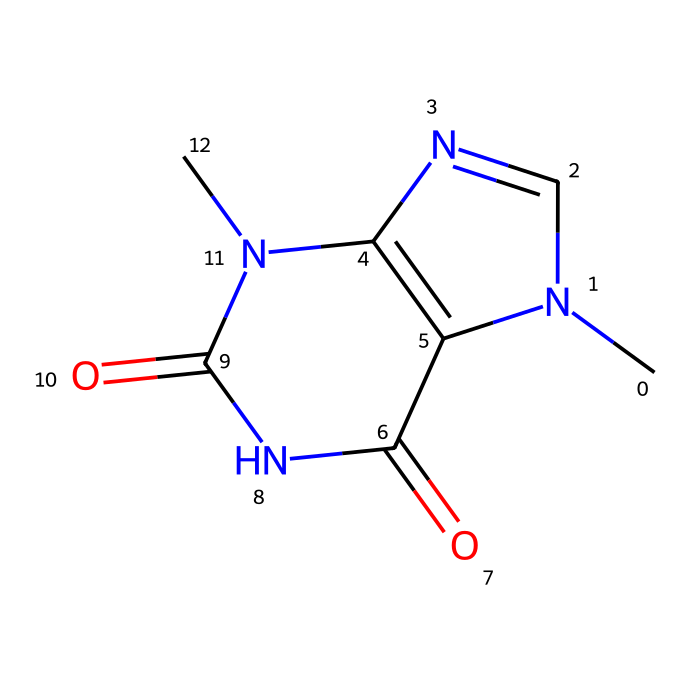What is the chemical name of this compound? The SMILES representation corresponds to a compound known as theobromine, which is characterized by its specific structure including nitrogen atoms and carbonyl groups.
Answer: theobromine How many nitrogen atoms are present in the chemical structure? By examining the SMILES representation, we can identify four nitrogen atoms present within the structure of theobromine.
Answer: four How many carbon atoms are in the compound? Counting the carbon atoms in the SMILES notation reveals a total of seven carbon atoms in the structure of theobromine.
Answer: seven What type of functional groups are present in this compound? The structure includes amide functional groups, as indicated by the presence of nitrogen directly bonded to carbonyl groups (C=O).
Answer: amide What does the presence of nitrogen suggest about the taste of this compound? The presence of nitrogen suggests that theobromine may contribute to a bitter taste, as nitrogen is commonly found in alkaloids associated with bitterness.
Answer: bitter Is this compound an alkaloid? Yes, theobromine is classified as an alkaloid due to its nitrogen content and pharmacological properties, which are characteristic of alkaloids.
Answer: yes Does this compound have any organosulfur extensions? The SMILES representation does not show sulfur atoms, which means theobromine does not have organosulfur extensions in its structure.
Answer: no 